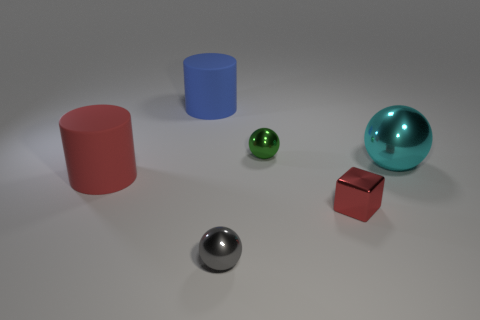Subtract all gray metal spheres. How many spheres are left? 2 Add 1 red cylinders. How many objects exist? 7 Subtract all gray balls. How many balls are left? 2 Subtract all blue spheres. Subtract all green cubes. How many spheres are left? 3 Subtract all cubes. How many objects are left? 5 Subtract all yellow spheres. Subtract all large metal spheres. How many objects are left? 5 Add 4 balls. How many balls are left? 7 Add 2 red blocks. How many red blocks exist? 3 Subtract 1 gray spheres. How many objects are left? 5 